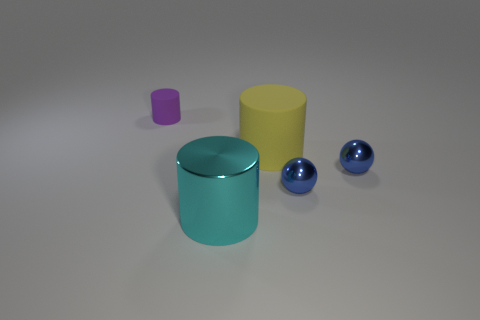What size is the purple object that is the same material as the large yellow thing? The purple object appears to be small in size in relation to the other objects in the image, and it shares a smooth, possibly metallic material with the larger yellow cylinder. 